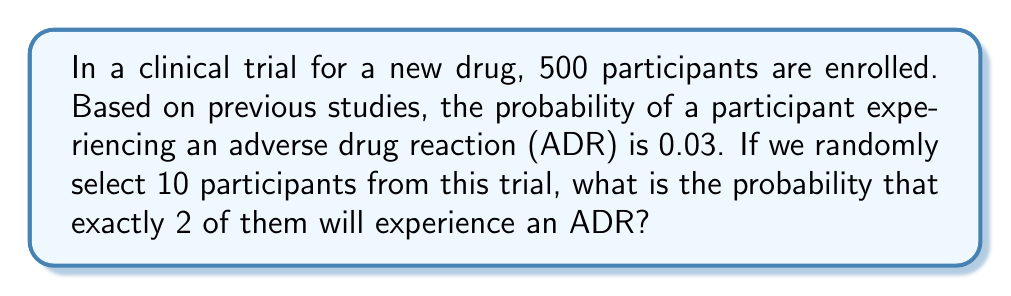Can you answer this question? To solve this problem, we need to use the binomial probability formula, as we are dealing with a fixed number of independent trials (selecting 10 participants) with a constant probability of success (experiencing an ADR) for each trial.

The binomial probability formula is:

$$P(X = k) = \binom{n}{k} p^k (1-p)^{n-k}$$

Where:
$n$ = number of trials (10 participants)
$k$ = number of successes (2 participants with ADR)
$p$ = probability of success on each trial (0.03)

Let's calculate step by step:

1. Calculate the binomial coefficient:
   $$\binom{10}{2} = \frac{10!}{2!(10-2)!} = \frac{10!}{2!8!} = 45$$

2. Calculate $p^k$:
   $$0.03^2 = 0.0009$$

3. Calculate $(1-p)^{n-k}$:
   $$(1-0.03)^{10-2} = 0.97^8 \approx 0.7836$$

4. Multiply all the components:
   $$45 \times 0.0009 \times 0.7836 \approx 0.0317$$

Therefore, the probability of exactly 2 out of 10 randomly selected participants experiencing an ADR is approximately 0.0317 or 3.17%.
Answer: $0.0317$ or $3.17\%$ 